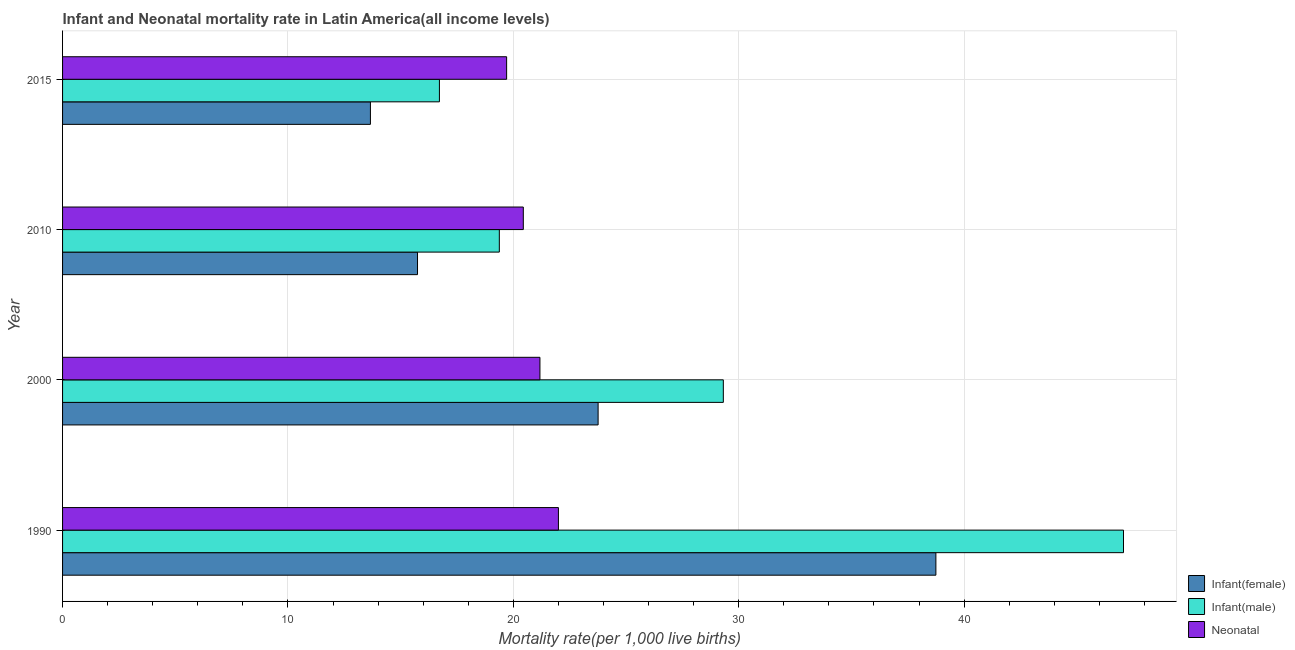How many groups of bars are there?
Your answer should be compact. 4. Are the number of bars on each tick of the Y-axis equal?
Give a very brief answer. Yes. How many bars are there on the 3rd tick from the bottom?
Provide a short and direct response. 3. What is the label of the 1st group of bars from the top?
Ensure brevity in your answer.  2015. What is the infant mortality rate(male) in 2000?
Offer a terse response. 29.32. Across all years, what is the maximum neonatal mortality rate?
Offer a very short reply. 22. Across all years, what is the minimum neonatal mortality rate?
Keep it short and to the point. 19.7. In which year was the infant mortality rate(female) minimum?
Your answer should be compact. 2015. What is the total infant mortality rate(female) in the graph?
Offer a very short reply. 91.91. What is the difference between the infant mortality rate(female) in 1990 and that in 2015?
Provide a short and direct response. 25.09. What is the difference between the neonatal mortality rate in 2010 and the infant mortality rate(male) in 2015?
Offer a very short reply. 3.72. What is the average infant mortality rate(male) per year?
Make the answer very short. 28.12. In the year 1990, what is the difference between the infant mortality rate(female) and neonatal mortality rate?
Offer a very short reply. 16.75. In how many years, is the infant mortality rate(female) greater than 38 ?
Your answer should be very brief. 1. What is the ratio of the neonatal mortality rate in 1990 to that in 2000?
Offer a terse response. 1.04. Is the neonatal mortality rate in 1990 less than that in 2000?
Provide a short and direct response. No. Is the difference between the infant mortality rate(male) in 2010 and 2015 greater than the difference between the neonatal mortality rate in 2010 and 2015?
Offer a terse response. Yes. What is the difference between the highest and the second highest neonatal mortality rate?
Provide a short and direct response. 0.82. What is the difference between the highest and the lowest infant mortality rate(female)?
Provide a short and direct response. 25.09. What does the 2nd bar from the top in 2015 represents?
Provide a short and direct response. Infant(male). What does the 2nd bar from the bottom in 1990 represents?
Offer a terse response. Infant(male). Is it the case that in every year, the sum of the infant mortality rate(female) and infant mortality rate(male) is greater than the neonatal mortality rate?
Offer a terse response. Yes. Are all the bars in the graph horizontal?
Your answer should be compact. Yes. How many years are there in the graph?
Offer a very short reply. 4. Are the values on the major ticks of X-axis written in scientific E-notation?
Your answer should be compact. No. Does the graph contain any zero values?
Offer a very short reply. No. Where does the legend appear in the graph?
Provide a short and direct response. Bottom right. How are the legend labels stacked?
Provide a succinct answer. Vertical. What is the title of the graph?
Provide a short and direct response. Infant and Neonatal mortality rate in Latin America(all income levels). What is the label or title of the X-axis?
Give a very brief answer. Mortality rate(per 1,0 live births). What is the label or title of the Y-axis?
Ensure brevity in your answer.  Year. What is the Mortality rate(per 1,000 live births) of Infant(female) in 1990?
Provide a short and direct response. 38.75. What is the Mortality rate(per 1,000 live births) of Infant(male) in 1990?
Give a very brief answer. 47.07. What is the Mortality rate(per 1,000 live births) of Neonatal  in 1990?
Provide a succinct answer. 22. What is the Mortality rate(per 1,000 live births) of Infant(female) in 2000?
Your answer should be compact. 23.76. What is the Mortality rate(per 1,000 live births) in Infant(male) in 2000?
Offer a very short reply. 29.32. What is the Mortality rate(per 1,000 live births) in Neonatal  in 2000?
Provide a short and direct response. 21.18. What is the Mortality rate(per 1,000 live births) of Infant(female) in 2010?
Offer a terse response. 15.75. What is the Mortality rate(per 1,000 live births) of Infant(male) in 2010?
Your answer should be very brief. 19.38. What is the Mortality rate(per 1,000 live births) of Neonatal  in 2010?
Ensure brevity in your answer.  20.44. What is the Mortality rate(per 1,000 live births) of Infant(female) in 2015?
Keep it short and to the point. 13.66. What is the Mortality rate(per 1,000 live births) in Infant(male) in 2015?
Your response must be concise. 16.72. What is the Mortality rate(per 1,000 live births) in Neonatal  in 2015?
Make the answer very short. 19.7. Across all years, what is the maximum Mortality rate(per 1,000 live births) in Infant(female)?
Offer a terse response. 38.75. Across all years, what is the maximum Mortality rate(per 1,000 live births) of Infant(male)?
Give a very brief answer. 47.07. Across all years, what is the maximum Mortality rate(per 1,000 live births) of Neonatal ?
Keep it short and to the point. 22. Across all years, what is the minimum Mortality rate(per 1,000 live births) in Infant(female)?
Keep it short and to the point. 13.66. Across all years, what is the minimum Mortality rate(per 1,000 live births) in Infant(male)?
Provide a short and direct response. 16.72. Across all years, what is the minimum Mortality rate(per 1,000 live births) in Neonatal ?
Your answer should be very brief. 19.7. What is the total Mortality rate(per 1,000 live births) in Infant(female) in the graph?
Make the answer very short. 91.91. What is the total Mortality rate(per 1,000 live births) in Infant(male) in the graph?
Offer a terse response. 112.49. What is the total Mortality rate(per 1,000 live births) in Neonatal  in the graph?
Offer a very short reply. 83.32. What is the difference between the Mortality rate(per 1,000 live births) in Infant(female) in 1990 and that in 2000?
Provide a succinct answer. 14.99. What is the difference between the Mortality rate(per 1,000 live births) in Infant(male) in 1990 and that in 2000?
Offer a terse response. 17.75. What is the difference between the Mortality rate(per 1,000 live births) of Neonatal  in 1990 and that in 2000?
Ensure brevity in your answer.  0.82. What is the difference between the Mortality rate(per 1,000 live births) of Infant(female) in 1990 and that in 2010?
Your response must be concise. 23. What is the difference between the Mortality rate(per 1,000 live births) in Infant(male) in 1990 and that in 2010?
Make the answer very short. 27.69. What is the difference between the Mortality rate(per 1,000 live births) in Neonatal  in 1990 and that in 2010?
Make the answer very short. 1.56. What is the difference between the Mortality rate(per 1,000 live births) of Infant(female) in 1990 and that in 2015?
Offer a very short reply. 25.09. What is the difference between the Mortality rate(per 1,000 live births) of Infant(male) in 1990 and that in 2015?
Your answer should be compact. 30.35. What is the difference between the Mortality rate(per 1,000 live births) of Neonatal  in 1990 and that in 2015?
Keep it short and to the point. 2.3. What is the difference between the Mortality rate(per 1,000 live births) of Infant(female) in 2000 and that in 2010?
Make the answer very short. 8.01. What is the difference between the Mortality rate(per 1,000 live births) in Infant(male) in 2000 and that in 2010?
Make the answer very short. 9.94. What is the difference between the Mortality rate(per 1,000 live births) of Neonatal  in 2000 and that in 2010?
Provide a succinct answer. 0.74. What is the difference between the Mortality rate(per 1,000 live births) in Infant(female) in 2000 and that in 2015?
Your answer should be compact. 10.1. What is the difference between the Mortality rate(per 1,000 live births) in Infant(male) in 2000 and that in 2015?
Your answer should be compact. 12.6. What is the difference between the Mortality rate(per 1,000 live births) in Neonatal  in 2000 and that in 2015?
Your answer should be compact. 1.48. What is the difference between the Mortality rate(per 1,000 live births) in Infant(female) in 2010 and that in 2015?
Your answer should be very brief. 2.09. What is the difference between the Mortality rate(per 1,000 live births) in Infant(male) in 2010 and that in 2015?
Your answer should be compact. 2.66. What is the difference between the Mortality rate(per 1,000 live births) of Neonatal  in 2010 and that in 2015?
Provide a short and direct response. 0.74. What is the difference between the Mortality rate(per 1,000 live births) in Infant(female) in 1990 and the Mortality rate(per 1,000 live births) in Infant(male) in 2000?
Make the answer very short. 9.43. What is the difference between the Mortality rate(per 1,000 live births) in Infant(female) in 1990 and the Mortality rate(per 1,000 live births) in Neonatal  in 2000?
Your response must be concise. 17.57. What is the difference between the Mortality rate(per 1,000 live births) in Infant(male) in 1990 and the Mortality rate(per 1,000 live births) in Neonatal  in 2000?
Your answer should be very brief. 25.89. What is the difference between the Mortality rate(per 1,000 live births) in Infant(female) in 1990 and the Mortality rate(per 1,000 live births) in Infant(male) in 2010?
Your answer should be very brief. 19.37. What is the difference between the Mortality rate(per 1,000 live births) in Infant(female) in 1990 and the Mortality rate(per 1,000 live births) in Neonatal  in 2010?
Give a very brief answer. 18.31. What is the difference between the Mortality rate(per 1,000 live births) in Infant(male) in 1990 and the Mortality rate(per 1,000 live births) in Neonatal  in 2010?
Ensure brevity in your answer.  26.63. What is the difference between the Mortality rate(per 1,000 live births) of Infant(female) in 1990 and the Mortality rate(per 1,000 live births) of Infant(male) in 2015?
Give a very brief answer. 22.03. What is the difference between the Mortality rate(per 1,000 live births) in Infant(female) in 1990 and the Mortality rate(per 1,000 live births) in Neonatal  in 2015?
Provide a succinct answer. 19.05. What is the difference between the Mortality rate(per 1,000 live births) in Infant(male) in 1990 and the Mortality rate(per 1,000 live births) in Neonatal  in 2015?
Keep it short and to the point. 27.37. What is the difference between the Mortality rate(per 1,000 live births) of Infant(female) in 2000 and the Mortality rate(per 1,000 live births) of Infant(male) in 2010?
Offer a terse response. 4.38. What is the difference between the Mortality rate(per 1,000 live births) of Infant(female) in 2000 and the Mortality rate(per 1,000 live births) of Neonatal  in 2010?
Provide a short and direct response. 3.32. What is the difference between the Mortality rate(per 1,000 live births) of Infant(male) in 2000 and the Mortality rate(per 1,000 live births) of Neonatal  in 2010?
Give a very brief answer. 8.87. What is the difference between the Mortality rate(per 1,000 live births) of Infant(female) in 2000 and the Mortality rate(per 1,000 live births) of Infant(male) in 2015?
Provide a succinct answer. 7.04. What is the difference between the Mortality rate(per 1,000 live births) in Infant(female) in 2000 and the Mortality rate(per 1,000 live births) in Neonatal  in 2015?
Offer a terse response. 4.06. What is the difference between the Mortality rate(per 1,000 live births) of Infant(male) in 2000 and the Mortality rate(per 1,000 live births) of Neonatal  in 2015?
Provide a short and direct response. 9.61. What is the difference between the Mortality rate(per 1,000 live births) in Infant(female) in 2010 and the Mortality rate(per 1,000 live births) in Infant(male) in 2015?
Keep it short and to the point. -0.97. What is the difference between the Mortality rate(per 1,000 live births) of Infant(female) in 2010 and the Mortality rate(per 1,000 live births) of Neonatal  in 2015?
Offer a terse response. -3.95. What is the difference between the Mortality rate(per 1,000 live births) in Infant(male) in 2010 and the Mortality rate(per 1,000 live births) in Neonatal  in 2015?
Your answer should be compact. -0.32. What is the average Mortality rate(per 1,000 live births) in Infant(female) per year?
Make the answer very short. 22.98. What is the average Mortality rate(per 1,000 live births) of Infant(male) per year?
Provide a short and direct response. 28.12. What is the average Mortality rate(per 1,000 live births) of Neonatal  per year?
Keep it short and to the point. 20.83. In the year 1990, what is the difference between the Mortality rate(per 1,000 live births) of Infant(female) and Mortality rate(per 1,000 live births) of Infant(male)?
Provide a succinct answer. -8.32. In the year 1990, what is the difference between the Mortality rate(per 1,000 live births) in Infant(female) and Mortality rate(per 1,000 live births) in Neonatal ?
Give a very brief answer. 16.75. In the year 1990, what is the difference between the Mortality rate(per 1,000 live births) in Infant(male) and Mortality rate(per 1,000 live births) in Neonatal ?
Offer a terse response. 25.07. In the year 2000, what is the difference between the Mortality rate(per 1,000 live births) in Infant(female) and Mortality rate(per 1,000 live births) in Infant(male)?
Ensure brevity in your answer.  -5.56. In the year 2000, what is the difference between the Mortality rate(per 1,000 live births) in Infant(female) and Mortality rate(per 1,000 live births) in Neonatal ?
Provide a short and direct response. 2.58. In the year 2000, what is the difference between the Mortality rate(per 1,000 live births) in Infant(male) and Mortality rate(per 1,000 live births) in Neonatal ?
Make the answer very short. 8.14. In the year 2010, what is the difference between the Mortality rate(per 1,000 live births) in Infant(female) and Mortality rate(per 1,000 live births) in Infant(male)?
Offer a terse response. -3.63. In the year 2010, what is the difference between the Mortality rate(per 1,000 live births) in Infant(female) and Mortality rate(per 1,000 live births) in Neonatal ?
Your answer should be compact. -4.69. In the year 2010, what is the difference between the Mortality rate(per 1,000 live births) in Infant(male) and Mortality rate(per 1,000 live births) in Neonatal ?
Give a very brief answer. -1.06. In the year 2015, what is the difference between the Mortality rate(per 1,000 live births) of Infant(female) and Mortality rate(per 1,000 live births) of Infant(male)?
Your answer should be very brief. -3.06. In the year 2015, what is the difference between the Mortality rate(per 1,000 live births) in Infant(female) and Mortality rate(per 1,000 live births) in Neonatal ?
Provide a succinct answer. -6.04. In the year 2015, what is the difference between the Mortality rate(per 1,000 live births) of Infant(male) and Mortality rate(per 1,000 live births) of Neonatal ?
Ensure brevity in your answer.  -2.98. What is the ratio of the Mortality rate(per 1,000 live births) in Infant(female) in 1990 to that in 2000?
Offer a terse response. 1.63. What is the ratio of the Mortality rate(per 1,000 live births) of Infant(male) in 1990 to that in 2000?
Offer a terse response. 1.61. What is the ratio of the Mortality rate(per 1,000 live births) in Neonatal  in 1990 to that in 2000?
Make the answer very short. 1.04. What is the ratio of the Mortality rate(per 1,000 live births) in Infant(female) in 1990 to that in 2010?
Your answer should be compact. 2.46. What is the ratio of the Mortality rate(per 1,000 live births) of Infant(male) in 1990 to that in 2010?
Give a very brief answer. 2.43. What is the ratio of the Mortality rate(per 1,000 live births) in Neonatal  in 1990 to that in 2010?
Provide a succinct answer. 1.08. What is the ratio of the Mortality rate(per 1,000 live births) in Infant(female) in 1990 to that in 2015?
Ensure brevity in your answer.  2.84. What is the ratio of the Mortality rate(per 1,000 live births) in Infant(male) in 1990 to that in 2015?
Provide a short and direct response. 2.82. What is the ratio of the Mortality rate(per 1,000 live births) of Neonatal  in 1990 to that in 2015?
Offer a very short reply. 1.12. What is the ratio of the Mortality rate(per 1,000 live births) of Infant(female) in 2000 to that in 2010?
Provide a short and direct response. 1.51. What is the ratio of the Mortality rate(per 1,000 live births) in Infant(male) in 2000 to that in 2010?
Provide a succinct answer. 1.51. What is the ratio of the Mortality rate(per 1,000 live births) of Neonatal  in 2000 to that in 2010?
Make the answer very short. 1.04. What is the ratio of the Mortality rate(per 1,000 live births) in Infant(female) in 2000 to that in 2015?
Your response must be concise. 1.74. What is the ratio of the Mortality rate(per 1,000 live births) in Infant(male) in 2000 to that in 2015?
Keep it short and to the point. 1.75. What is the ratio of the Mortality rate(per 1,000 live births) in Neonatal  in 2000 to that in 2015?
Provide a short and direct response. 1.07. What is the ratio of the Mortality rate(per 1,000 live births) of Infant(female) in 2010 to that in 2015?
Give a very brief answer. 1.15. What is the ratio of the Mortality rate(per 1,000 live births) in Infant(male) in 2010 to that in 2015?
Provide a succinct answer. 1.16. What is the ratio of the Mortality rate(per 1,000 live births) in Neonatal  in 2010 to that in 2015?
Keep it short and to the point. 1.04. What is the difference between the highest and the second highest Mortality rate(per 1,000 live births) in Infant(female)?
Provide a short and direct response. 14.99. What is the difference between the highest and the second highest Mortality rate(per 1,000 live births) in Infant(male)?
Offer a terse response. 17.75. What is the difference between the highest and the second highest Mortality rate(per 1,000 live births) of Neonatal ?
Provide a short and direct response. 0.82. What is the difference between the highest and the lowest Mortality rate(per 1,000 live births) in Infant(female)?
Your answer should be very brief. 25.09. What is the difference between the highest and the lowest Mortality rate(per 1,000 live births) of Infant(male)?
Your answer should be compact. 30.35. What is the difference between the highest and the lowest Mortality rate(per 1,000 live births) of Neonatal ?
Your response must be concise. 2.3. 